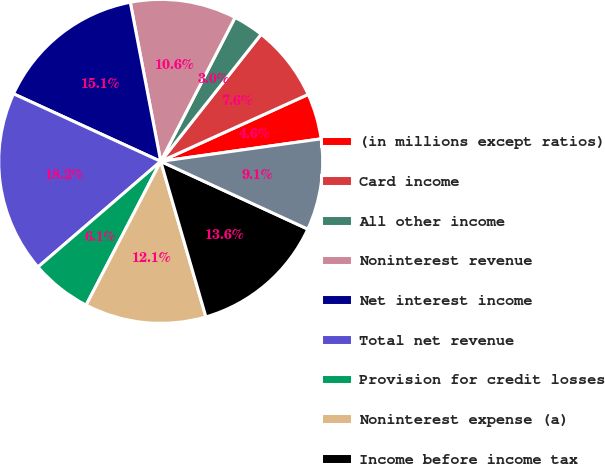Convert chart. <chart><loc_0><loc_0><loc_500><loc_500><pie_chart><fcel>(in millions except ratios)<fcel>Card income<fcel>All other income<fcel>Noninterest revenue<fcel>Net interest income<fcel>Total net revenue<fcel>Provision for credit losses<fcel>Noninterest expense (a)<fcel>Income before income tax<fcel>Net income<nl><fcel>4.56%<fcel>7.58%<fcel>3.05%<fcel>10.6%<fcel>15.14%<fcel>18.16%<fcel>6.07%<fcel>12.12%<fcel>13.63%<fcel>9.09%<nl></chart> 